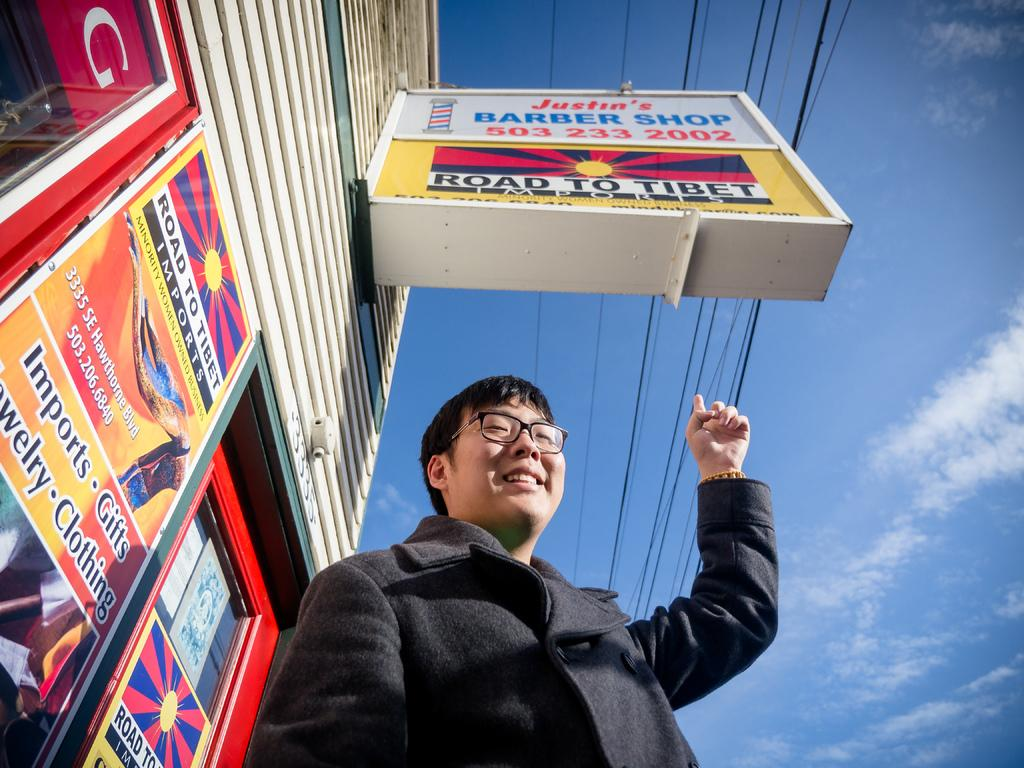<image>
Present a compact description of the photo's key features. A man stands under a barber shop sign and points to it. 